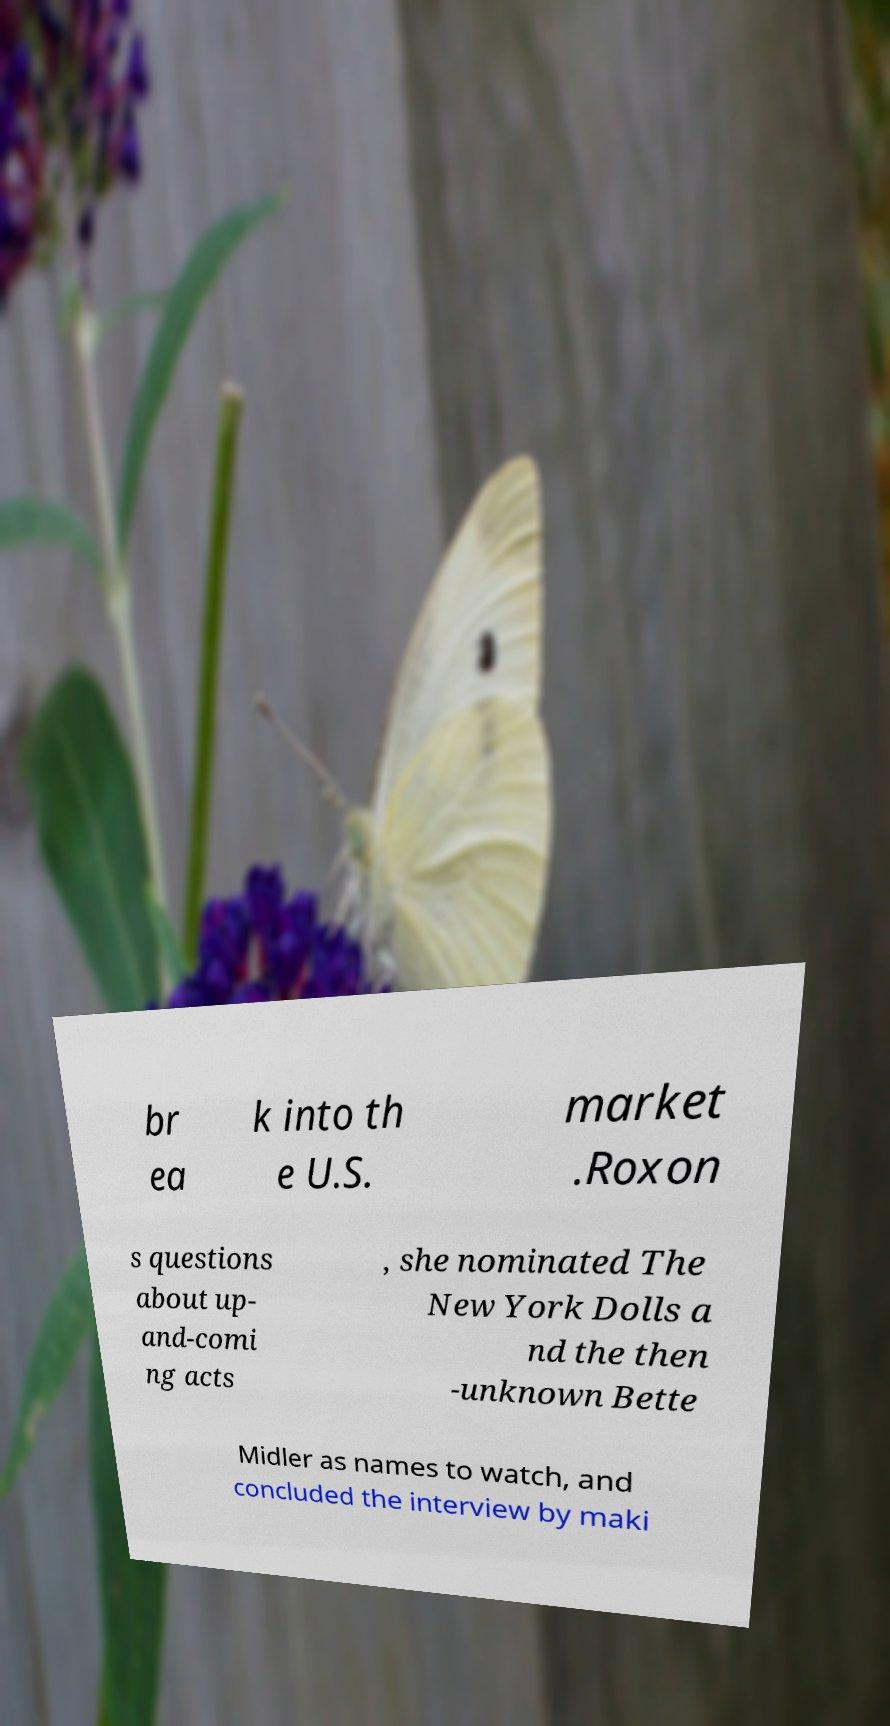There's text embedded in this image that I need extracted. Can you transcribe it verbatim? br ea k into th e U.S. market .Roxon s questions about up- and-comi ng acts , she nominated The New York Dolls a nd the then -unknown Bette Midler as names to watch, and concluded the interview by maki 